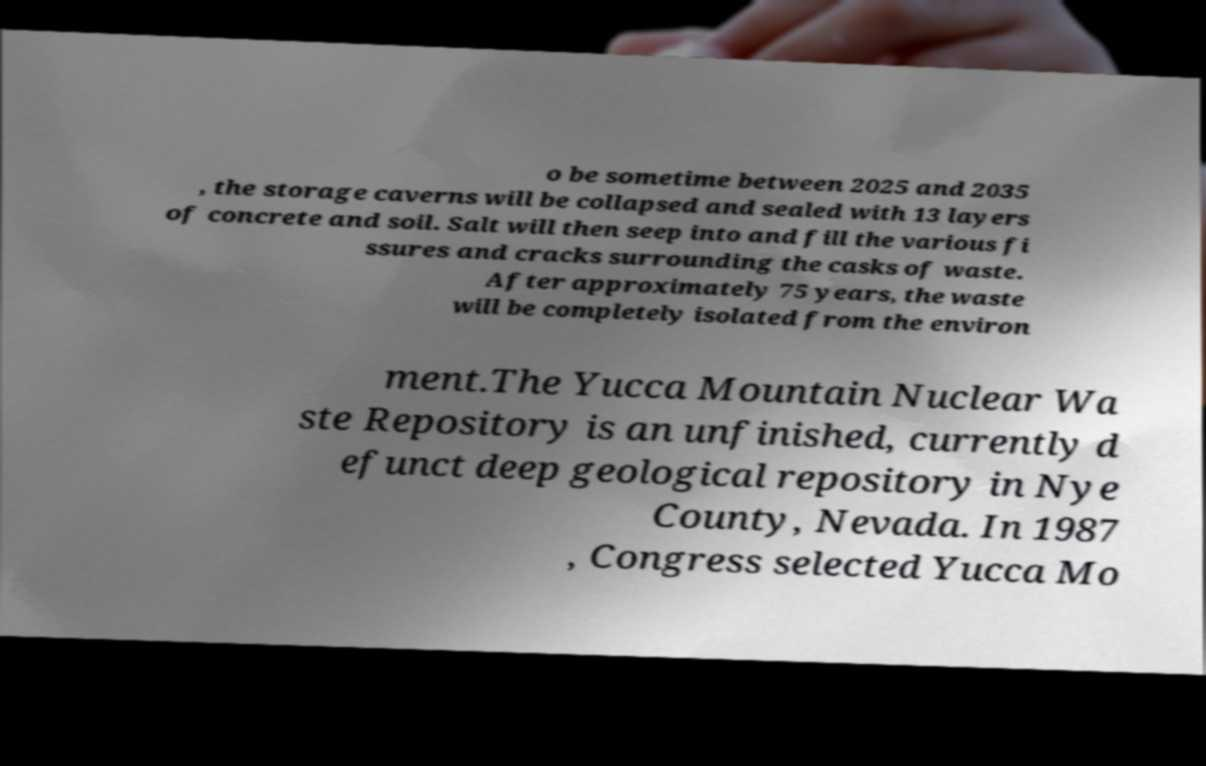Please identify and transcribe the text found in this image. o be sometime between 2025 and 2035 , the storage caverns will be collapsed and sealed with 13 layers of concrete and soil. Salt will then seep into and fill the various fi ssures and cracks surrounding the casks of waste. After approximately 75 years, the waste will be completely isolated from the environ ment.The Yucca Mountain Nuclear Wa ste Repository is an unfinished, currently d efunct deep geological repository in Nye County, Nevada. In 1987 , Congress selected Yucca Mo 